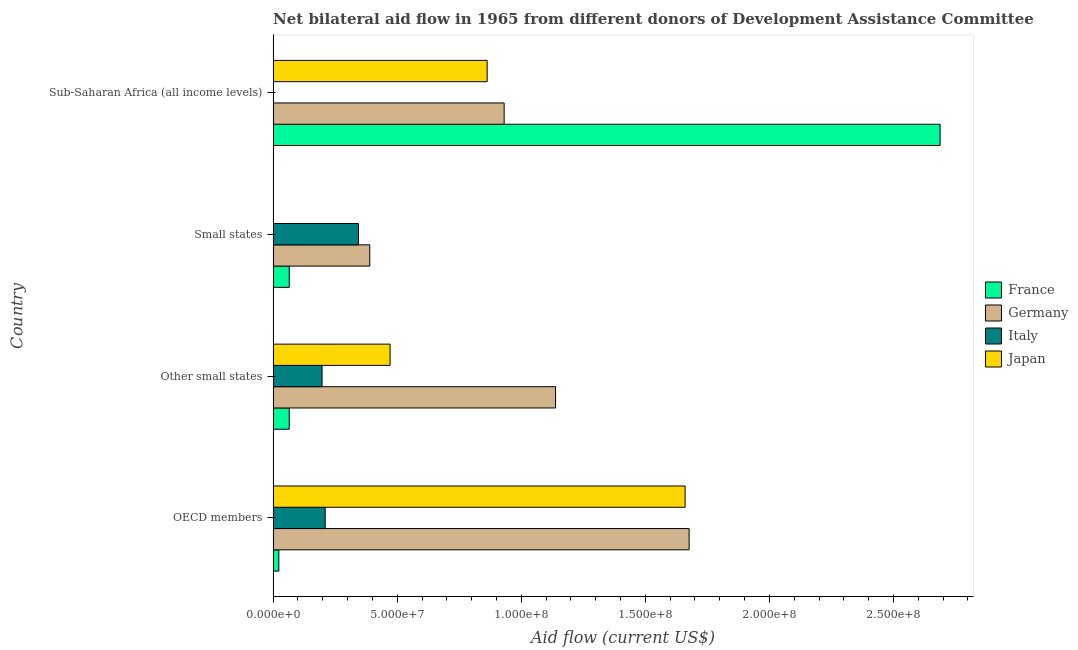Are the number of bars on each tick of the Y-axis equal?
Your answer should be compact. Yes. How many bars are there on the 1st tick from the bottom?
Offer a terse response. 4. What is the label of the 2nd group of bars from the top?
Offer a terse response. Small states. In how many cases, is the number of bars for a given country not equal to the number of legend labels?
Your response must be concise. 0. What is the amount of aid given by france in Sub-Saharan Africa (all income levels)?
Make the answer very short. 2.69e+08. Across all countries, what is the maximum amount of aid given by france?
Your response must be concise. 2.69e+08. Across all countries, what is the minimum amount of aid given by japan?
Give a very brief answer. 10000. In which country was the amount of aid given by germany maximum?
Your response must be concise. OECD members. In which country was the amount of aid given by japan minimum?
Offer a terse response. Small states. What is the total amount of aid given by japan in the graph?
Your answer should be compact. 2.99e+08. What is the difference between the amount of aid given by germany in Other small states and that in Sub-Saharan Africa (all income levels)?
Keep it short and to the point. 2.07e+07. What is the difference between the amount of aid given by france in Sub-Saharan Africa (all income levels) and the amount of aid given by japan in Small states?
Offer a terse response. 2.69e+08. What is the average amount of aid given by germany per country?
Ensure brevity in your answer.  1.03e+08. What is the difference between the amount of aid given by japan and amount of aid given by germany in Small states?
Your answer should be compact. -3.89e+07. In how many countries, is the amount of aid given by italy greater than 50000000 US$?
Offer a terse response. 0. What is the ratio of the amount of aid given by france in Other small states to that in Small states?
Offer a terse response. 1. What is the difference between the highest and the second highest amount of aid given by france?
Your response must be concise. 2.62e+08. What is the difference between the highest and the lowest amount of aid given by germany?
Offer a very short reply. 1.29e+08. Is it the case that in every country, the sum of the amount of aid given by japan and amount of aid given by france is greater than the sum of amount of aid given by germany and amount of aid given by italy?
Give a very brief answer. No. What does the 2nd bar from the top in Sub-Saharan Africa (all income levels) represents?
Provide a succinct answer. Italy. What does the 4th bar from the bottom in OECD members represents?
Provide a short and direct response. Japan. Is it the case that in every country, the sum of the amount of aid given by france and amount of aid given by germany is greater than the amount of aid given by italy?
Ensure brevity in your answer.  Yes. How many bars are there?
Your answer should be very brief. 16. Are all the bars in the graph horizontal?
Make the answer very short. Yes. How many countries are there in the graph?
Ensure brevity in your answer.  4. Does the graph contain any zero values?
Make the answer very short. No. How many legend labels are there?
Offer a very short reply. 4. How are the legend labels stacked?
Keep it short and to the point. Vertical. What is the title of the graph?
Provide a short and direct response. Net bilateral aid flow in 1965 from different donors of Development Assistance Committee. What is the label or title of the X-axis?
Your response must be concise. Aid flow (current US$). What is the Aid flow (current US$) of France in OECD members?
Your response must be concise. 2.30e+06. What is the Aid flow (current US$) in Germany in OECD members?
Provide a succinct answer. 1.68e+08. What is the Aid flow (current US$) in Italy in OECD members?
Your answer should be very brief. 2.10e+07. What is the Aid flow (current US$) in Japan in OECD members?
Give a very brief answer. 1.66e+08. What is the Aid flow (current US$) of France in Other small states?
Your answer should be compact. 6.50e+06. What is the Aid flow (current US$) in Germany in Other small states?
Your response must be concise. 1.14e+08. What is the Aid flow (current US$) of Italy in Other small states?
Provide a short and direct response. 1.97e+07. What is the Aid flow (current US$) in Japan in Other small states?
Give a very brief answer. 4.71e+07. What is the Aid flow (current US$) in France in Small states?
Provide a short and direct response. 6.50e+06. What is the Aid flow (current US$) of Germany in Small states?
Give a very brief answer. 3.89e+07. What is the Aid flow (current US$) of Italy in Small states?
Offer a very short reply. 3.44e+07. What is the Aid flow (current US$) in Japan in Small states?
Make the answer very short. 10000. What is the Aid flow (current US$) of France in Sub-Saharan Africa (all income levels)?
Provide a succinct answer. 2.69e+08. What is the Aid flow (current US$) in Germany in Sub-Saharan Africa (all income levels)?
Your answer should be compact. 9.31e+07. What is the Aid flow (current US$) of Japan in Sub-Saharan Africa (all income levels)?
Make the answer very short. 8.62e+07. Across all countries, what is the maximum Aid flow (current US$) of France?
Offer a very short reply. 2.69e+08. Across all countries, what is the maximum Aid flow (current US$) in Germany?
Offer a terse response. 1.68e+08. Across all countries, what is the maximum Aid flow (current US$) in Italy?
Offer a very short reply. 3.44e+07. Across all countries, what is the maximum Aid flow (current US$) of Japan?
Give a very brief answer. 1.66e+08. Across all countries, what is the minimum Aid flow (current US$) of France?
Your answer should be compact. 2.30e+06. Across all countries, what is the minimum Aid flow (current US$) in Germany?
Make the answer very short. 3.89e+07. Across all countries, what is the minimum Aid flow (current US$) of Italy?
Your response must be concise. 8.00e+04. What is the total Aid flow (current US$) of France in the graph?
Offer a very short reply. 2.84e+08. What is the total Aid flow (current US$) in Germany in the graph?
Offer a very short reply. 4.14e+08. What is the total Aid flow (current US$) in Italy in the graph?
Give a very brief answer. 7.52e+07. What is the total Aid flow (current US$) of Japan in the graph?
Your answer should be very brief. 2.99e+08. What is the difference between the Aid flow (current US$) in France in OECD members and that in Other small states?
Offer a terse response. -4.20e+06. What is the difference between the Aid flow (current US$) of Germany in OECD members and that in Other small states?
Give a very brief answer. 5.38e+07. What is the difference between the Aid flow (current US$) of Italy in OECD members and that in Other small states?
Offer a very short reply. 1.26e+06. What is the difference between the Aid flow (current US$) in Japan in OECD members and that in Other small states?
Keep it short and to the point. 1.19e+08. What is the difference between the Aid flow (current US$) in France in OECD members and that in Small states?
Your response must be concise. -4.20e+06. What is the difference between the Aid flow (current US$) of Germany in OECD members and that in Small states?
Ensure brevity in your answer.  1.29e+08. What is the difference between the Aid flow (current US$) in Italy in OECD members and that in Small states?
Provide a succinct answer. -1.34e+07. What is the difference between the Aid flow (current US$) in Japan in OECD members and that in Small states?
Your answer should be compact. 1.66e+08. What is the difference between the Aid flow (current US$) in France in OECD members and that in Sub-Saharan Africa (all income levels)?
Your answer should be compact. -2.66e+08. What is the difference between the Aid flow (current US$) in Germany in OECD members and that in Sub-Saharan Africa (all income levels)?
Make the answer very short. 7.46e+07. What is the difference between the Aid flow (current US$) in Italy in OECD members and that in Sub-Saharan Africa (all income levels)?
Provide a succinct answer. 2.09e+07. What is the difference between the Aid flow (current US$) of Japan in OECD members and that in Sub-Saharan Africa (all income levels)?
Keep it short and to the point. 7.98e+07. What is the difference between the Aid flow (current US$) in France in Other small states and that in Small states?
Provide a succinct answer. 0. What is the difference between the Aid flow (current US$) in Germany in Other small states and that in Small states?
Your answer should be very brief. 7.49e+07. What is the difference between the Aid flow (current US$) of Italy in Other small states and that in Small states?
Provide a short and direct response. -1.47e+07. What is the difference between the Aid flow (current US$) in Japan in Other small states and that in Small states?
Your answer should be compact. 4.71e+07. What is the difference between the Aid flow (current US$) of France in Other small states and that in Sub-Saharan Africa (all income levels)?
Your answer should be compact. -2.62e+08. What is the difference between the Aid flow (current US$) of Germany in Other small states and that in Sub-Saharan Africa (all income levels)?
Provide a short and direct response. 2.07e+07. What is the difference between the Aid flow (current US$) of Italy in Other small states and that in Sub-Saharan Africa (all income levels)?
Your answer should be compact. 1.96e+07. What is the difference between the Aid flow (current US$) in Japan in Other small states and that in Sub-Saharan Africa (all income levels)?
Provide a succinct answer. -3.91e+07. What is the difference between the Aid flow (current US$) in France in Small states and that in Sub-Saharan Africa (all income levels)?
Give a very brief answer. -2.62e+08. What is the difference between the Aid flow (current US$) of Germany in Small states and that in Sub-Saharan Africa (all income levels)?
Keep it short and to the point. -5.42e+07. What is the difference between the Aid flow (current US$) of Italy in Small states and that in Sub-Saharan Africa (all income levels)?
Ensure brevity in your answer.  3.43e+07. What is the difference between the Aid flow (current US$) of Japan in Small states and that in Sub-Saharan Africa (all income levels)?
Provide a succinct answer. -8.62e+07. What is the difference between the Aid flow (current US$) of France in OECD members and the Aid flow (current US$) of Germany in Other small states?
Your response must be concise. -1.12e+08. What is the difference between the Aid flow (current US$) in France in OECD members and the Aid flow (current US$) in Italy in Other small states?
Your answer should be very brief. -1.74e+07. What is the difference between the Aid flow (current US$) in France in OECD members and the Aid flow (current US$) in Japan in Other small states?
Give a very brief answer. -4.48e+07. What is the difference between the Aid flow (current US$) in Germany in OECD members and the Aid flow (current US$) in Italy in Other small states?
Ensure brevity in your answer.  1.48e+08. What is the difference between the Aid flow (current US$) in Germany in OECD members and the Aid flow (current US$) in Japan in Other small states?
Give a very brief answer. 1.21e+08. What is the difference between the Aid flow (current US$) in Italy in OECD members and the Aid flow (current US$) in Japan in Other small states?
Provide a short and direct response. -2.62e+07. What is the difference between the Aid flow (current US$) of France in OECD members and the Aid flow (current US$) of Germany in Small states?
Ensure brevity in your answer.  -3.66e+07. What is the difference between the Aid flow (current US$) of France in OECD members and the Aid flow (current US$) of Italy in Small states?
Keep it short and to the point. -3.21e+07. What is the difference between the Aid flow (current US$) of France in OECD members and the Aid flow (current US$) of Japan in Small states?
Provide a short and direct response. 2.29e+06. What is the difference between the Aid flow (current US$) in Germany in OECD members and the Aid flow (current US$) in Italy in Small states?
Give a very brief answer. 1.33e+08. What is the difference between the Aid flow (current US$) of Germany in OECD members and the Aid flow (current US$) of Japan in Small states?
Your answer should be compact. 1.68e+08. What is the difference between the Aid flow (current US$) of Italy in OECD members and the Aid flow (current US$) of Japan in Small states?
Provide a succinct answer. 2.10e+07. What is the difference between the Aid flow (current US$) of France in OECD members and the Aid flow (current US$) of Germany in Sub-Saharan Africa (all income levels)?
Your response must be concise. -9.08e+07. What is the difference between the Aid flow (current US$) in France in OECD members and the Aid flow (current US$) in Italy in Sub-Saharan Africa (all income levels)?
Offer a terse response. 2.22e+06. What is the difference between the Aid flow (current US$) in France in OECD members and the Aid flow (current US$) in Japan in Sub-Saharan Africa (all income levels)?
Your answer should be very brief. -8.40e+07. What is the difference between the Aid flow (current US$) in Germany in OECD members and the Aid flow (current US$) in Italy in Sub-Saharan Africa (all income levels)?
Your response must be concise. 1.68e+08. What is the difference between the Aid flow (current US$) of Germany in OECD members and the Aid flow (current US$) of Japan in Sub-Saharan Africa (all income levels)?
Make the answer very short. 8.14e+07. What is the difference between the Aid flow (current US$) in Italy in OECD members and the Aid flow (current US$) in Japan in Sub-Saharan Africa (all income levels)?
Provide a short and direct response. -6.53e+07. What is the difference between the Aid flow (current US$) in France in Other small states and the Aid flow (current US$) in Germany in Small states?
Ensure brevity in your answer.  -3.24e+07. What is the difference between the Aid flow (current US$) of France in Other small states and the Aid flow (current US$) of Italy in Small states?
Offer a very short reply. -2.79e+07. What is the difference between the Aid flow (current US$) in France in Other small states and the Aid flow (current US$) in Japan in Small states?
Provide a short and direct response. 6.49e+06. What is the difference between the Aid flow (current US$) of Germany in Other small states and the Aid flow (current US$) of Italy in Small states?
Make the answer very short. 7.94e+07. What is the difference between the Aid flow (current US$) in Germany in Other small states and the Aid flow (current US$) in Japan in Small states?
Your answer should be very brief. 1.14e+08. What is the difference between the Aid flow (current US$) of Italy in Other small states and the Aid flow (current US$) of Japan in Small states?
Give a very brief answer. 1.97e+07. What is the difference between the Aid flow (current US$) in France in Other small states and the Aid flow (current US$) in Germany in Sub-Saharan Africa (all income levels)?
Your answer should be very brief. -8.66e+07. What is the difference between the Aid flow (current US$) in France in Other small states and the Aid flow (current US$) in Italy in Sub-Saharan Africa (all income levels)?
Provide a short and direct response. 6.42e+06. What is the difference between the Aid flow (current US$) in France in Other small states and the Aid flow (current US$) in Japan in Sub-Saharan Africa (all income levels)?
Ensure brevity in your answer.  -7.98e+07. What is the difference between the Aid flow (current US$) of Germany in Other small states and the Aid flow (current US$) of Italy in Sub-Saharan Africa (all income levels)?
Your answer should be very brief. 1.14e+08. What is the difference between the Aid flow (current US$) in Germany in Other small states and the Aid flow (current US$) in Japan in Sub-Saharan Africa (all income levels)?
Provide a succinct answer. 2.76e+07. What is the difference between the Aid flow (current US$) in Italy in Other small states and the Aid flow (current US$) in Japan in Sub-Saharan Africa (all income levels)?
Your answer should be very brief. -6.65e+07. What is the difference between the Aid flow (current US$) of France in Small states and the Aid flow (current US$) of Germany in Sub-Saharan Africa (all income levels)?
Make the answer very short. -8.66e+07. What is the difference between the Aid flow (current US$) in France in Small states and the Aid flow (current US$) in Italy in Sub-Saharan Africa (all income levels)?
Provide a succinct answer. 6.42e+06. What is the difference between the Aid flow (current US$) of France in Small states and the Aid flow (current US$) of Japan in Sub-Saharan Africa (all income levels)?
Ensure brevity in your answer.  -7.98e+07. What is the difference between the Aid flow (current US$) in Germany in Small states and the Aid flow (current US$) in Italy in Sub-Saharan Africa (all income levels)?
Your answer should be compact. 3.89e+07. What is the difference between the Aid flow (current US$) in Germany in Small states and the Aid flow (current US$) in Japan in Sub-Saharan Africa (all income levels)?
Your answer should be very brief. -4.73e+07. What is the difference between the Aid flow (current US$) of Italy in Small states and the Aid flow (current US$) of Japan in Sub-Saharan Africa (all income levels)?
Provide a succinct answer. -5.19e+07. What is the average Aid flow (current US$) of France per country?
Offer a terse response. 7.10e+07. What is the average Aid flow (current US$) in Germany per country?
Keep it short and to the point. 1.03e+08. What is the average Aid flow (current US$) in Italy per country?
Offer a very short reply. 1.88e+07. What is the average Aid flow (current US$) in Japan per country?
Give a very brief answer. 7.49e+07. What is the difference between the Aid flow (current US$) in France and Aid flow (current US$) in Germany in OECD members?
Give a very brief answer. -1.65e+08. What is the difference between the Aid flow (current US$) of France and Aid flow (current US$) of Italy in OECD members?
Keep it short and to the point. -1.87e+07. What is the difference between the Aid flow (current US$) of France and Aid flow (current US$) of Japan in OECD members?
Make the answer very short. -1.64e+08. What is the difference between the Aid flow (current US$) of Germany and Aid flow (current US$) of Italy in OECD members?
Provide a short and direct response. 1.47e+08. What is the difference between the Aid flow (current US$) of Germany and Aid flow (current US$) of Japan in OECD members?
Offer a very short reply. 1.62e+06. What is the difference between the Aid flow (current US$) of Italy and Aid flow (current US$) of Japan in OECD members?
Your response must be concise. -1.45e+08. What is the difference between the Aid flow (current US$) in France and Aid flow (current US$) in Germany in Other small states?
Offer a terse response. -1.07e+08. What is the difference between the Aid flow (current US$) of France and Aid flow (current US$) of Italy in Other small states?
Ensure brevity in your answer.  -1.32e+07. What is the difference between the Aid flow (current US$) in France and Aid flow (current US$) in Japan in Other small states?
Offer a very short reply. -4.06e+07. What is the difference between the Aid flow (current US$) in Germany and Aid flow (current US$) in Italy in Other small states?
Offer a very short reply. 9.41e+07. What is the difference between the Aid flow (current US$) of Germany and Aid flow (current US$) of Japan in Other small states?
Your answer should be compact. 6.67e+07. What is the difference between the Aid flow (current US$) in Italy and Aid flow (current US$) in Japan in Other small states?
Provide a succinct answer. -2.74e+07. What is the difference between the Aid flow (current US$) of France and Aid flow (current US$) of Germany in Small states?
Your response must be concise. -3.24e+07. What is the difference between the Aid flow (current US$) of France and Aid flow (current US$) of Italy in Small states?
Your response must be concise. -2.79e+07. What is the difference between the Aid flow (current US$) of France and Aid flow (current US$) of Japan in Small states?
Make the answer very short. 6.49e+06. What is the difference between the Aid flow (current US$) in Germany and Aid flow (current US$) in Italy in Small states?
Provide a succinct answer. 4.56e+06. What is the difference between the Aid flow (current US$) of Germany and Aid flow (current US$) of Japan in Small states?
Make the answer very short. 3.89e+07. What is the difference between the Aid flow (current US$) of Italy and Aid flow (current US$) of Japan in Small states?
Provide a short and direct response. 3.44e+07. What is the difference between the Aid flow (current US$) of France and Aid flow (current US$) of Germany in Sub-Saharan Africa (all income levels)?
Ensure brevity in your answer.  1.76e+08. What is the difference between the Aid flow (current US$) of France and Aid flow (current US$) of Italy in Sub-Saharan Africa (all income levels)?
Keep it short and to the point. 2.69e+08. What is the difference between the Aid flow (current US$) of France and Aid flow (current US$) of Japan in Sub-Saharan Africa (all income levels)?
Provide a succinct answer. 1.83e+08. What is the difference between the Aid flow (current US$) in Germany and Aid flow (current US$) in Italy in Sub-Saharan Africa (all income levels)?
Your answer should be very brief. 9.30e+07. What is the difference between the Aid flow (current US$) of Germany and Aid flow (current US$) of Japan in Sub-Saharan Africa (all income levels)?
Your answer should be compact. 6.85e+06. What is the difference between the Aid flow (current US$) of Italy and Aid flow (current US$) of Japan in Sub-Saharan Africa (all income levels)?
Give a very brief answer. -8.62e+07. What is the ratio of the Aid flow (current US$) in France in OECD members to that in Other small states?
Provide a succinct answer. 0.35. What is the ratio of the Aid flow (current US$) of Germany in OECD members to that in Other small states?
Provide a succinct answer. 1.47. What is the ratio of the Aid flow (current US$) in Italy in OECD members to that in Other small states?
Offer a very short reply. 1.06. What is the ratio of the Aid flow (current US$) of Japan in OECD members to that in Other small states?
Give a very brief answer. 3.52. What is the ratio of the Aid flow (current US$) in France in OECD members to that in Small states?
Provide a succinct answer. 0.35. What is the ratio of the Aid flow (current US$) of Germany in OECD members to that in Small states?
Your response must be concise. 4.31. What is the ratio of the Aid flow (current US$) of Italy in OECD members to that in Small states?
Ensure brevity in your answer.  0.61. What is the ratio of the Aid flow (current US$) of Japan in OECD members to that in Small states?
Make the answer very short. 1.66e+04. What is the ratio of the Aid flow (current US$) of France in OECD members to that in Sub-Saharan Africa (all income levels)?
Your answer should be very brief. 0.01. What is the ratio of the Aid flow (current US$) of Germany in OECD members to that in Sub-Saharan Africa (all income levels)?
Your answer should be very brief. 1.8. What is the ratio of the Aid flow (current US$) in Italy in OECD members to that in Sub-Saharan Africa (all income levels)?
Ensure brevity in your answer.  262.25. What is the ratio of the Aid flow (current US$) in Japan in OECD members to that in Sub-Saharan Africa (all income levels)?
Give a very brief answer. 1.93. What is the ratio of the Aid flow (current US$) in France in Other small states to that in Small states?
Provide a short and direct response. 1. What is the ratio of the Aid flow (current US$) in Germany in Other small states to that in Small states?
Make the answer very short. 2.92. What is the ratio of the Aid flow (current US$) in Italy in Other small states to that in Small states?
Ensure brevity in your answer.  0.57. What is the ratio of the Aid flow (current US$) in Japan in Other small states to that in Small states?
Provide a short and direct response. 4714. What is the ratio of the Aid flow (current US$) of France in Other small states to that in Sub-Saharan Africa (all income levels)?
Keep it short and to the point. 0.02. What is the ratio of the Aid flow (current US$) of Germany in Other small states to that in Sub-Saharan Africa (all income levels)?
Ensure brevity in your answer.  1.22. What is the ratio of the Aid flow (current US$) of Italy in Other small states to that in Sub-Saharan Africa (all income levels)?
Offer a very short reply. 246.5. What is the ratio of the Aid flow (current US$) in Japan in Other small states to that in Sub-Saharan Africa (all income levels)?
Offer a terse response. 0.55. What is the ratio of the Aid flow (current US$) in France in Small states to that in Sub-Saharan Africa (all income levels)?
Your answer should be very brief. 0.02. What is the ratio of the Aid flow (current US$) of Germany in Small states to that in Sub-Saharan Africa (all income levels)?
Provide a short and direct response. 0.42. What is the ratio of the Aid flow (current US$) of Italy in Small states to that in Sub-Saharan Africa (all income levels)?
Give a very brief answer. 429.75. What is the difference between the highest and the second highest Aid flow (current US$) in France?
Provide a succinct answer. 2.62e+08. What is the difference between the highest and the second highest Aid flow (current US$) in Germany?
Keep it short and to the point. 5.38e+07. What is the difference between the highest and the second highest Aid flow (current US$) in Italy?
Offer a terse response. 1.34e+07. What is the difference between the highest and the second highest Aid flow (current US$) in Japan?
Your answer should be compact. 7.98e+07. What is the difference between the highest and the lowest Aid flow (current US$) in France?
Your answer should be compact. 2.66e+08. What is the difference between the highest and the lowest Aid flow (current US$) of Germany?
Your response must be concise. 1.29e+08. What is the difference between the highest and the lowest Aid flow (current US$) of Italy?
Make the answer very short. 3.43e+07. What is the difference between the highest and the lowest Aid flow (current US$) of Japan?
Your response must be concise. 1.66e+08. 